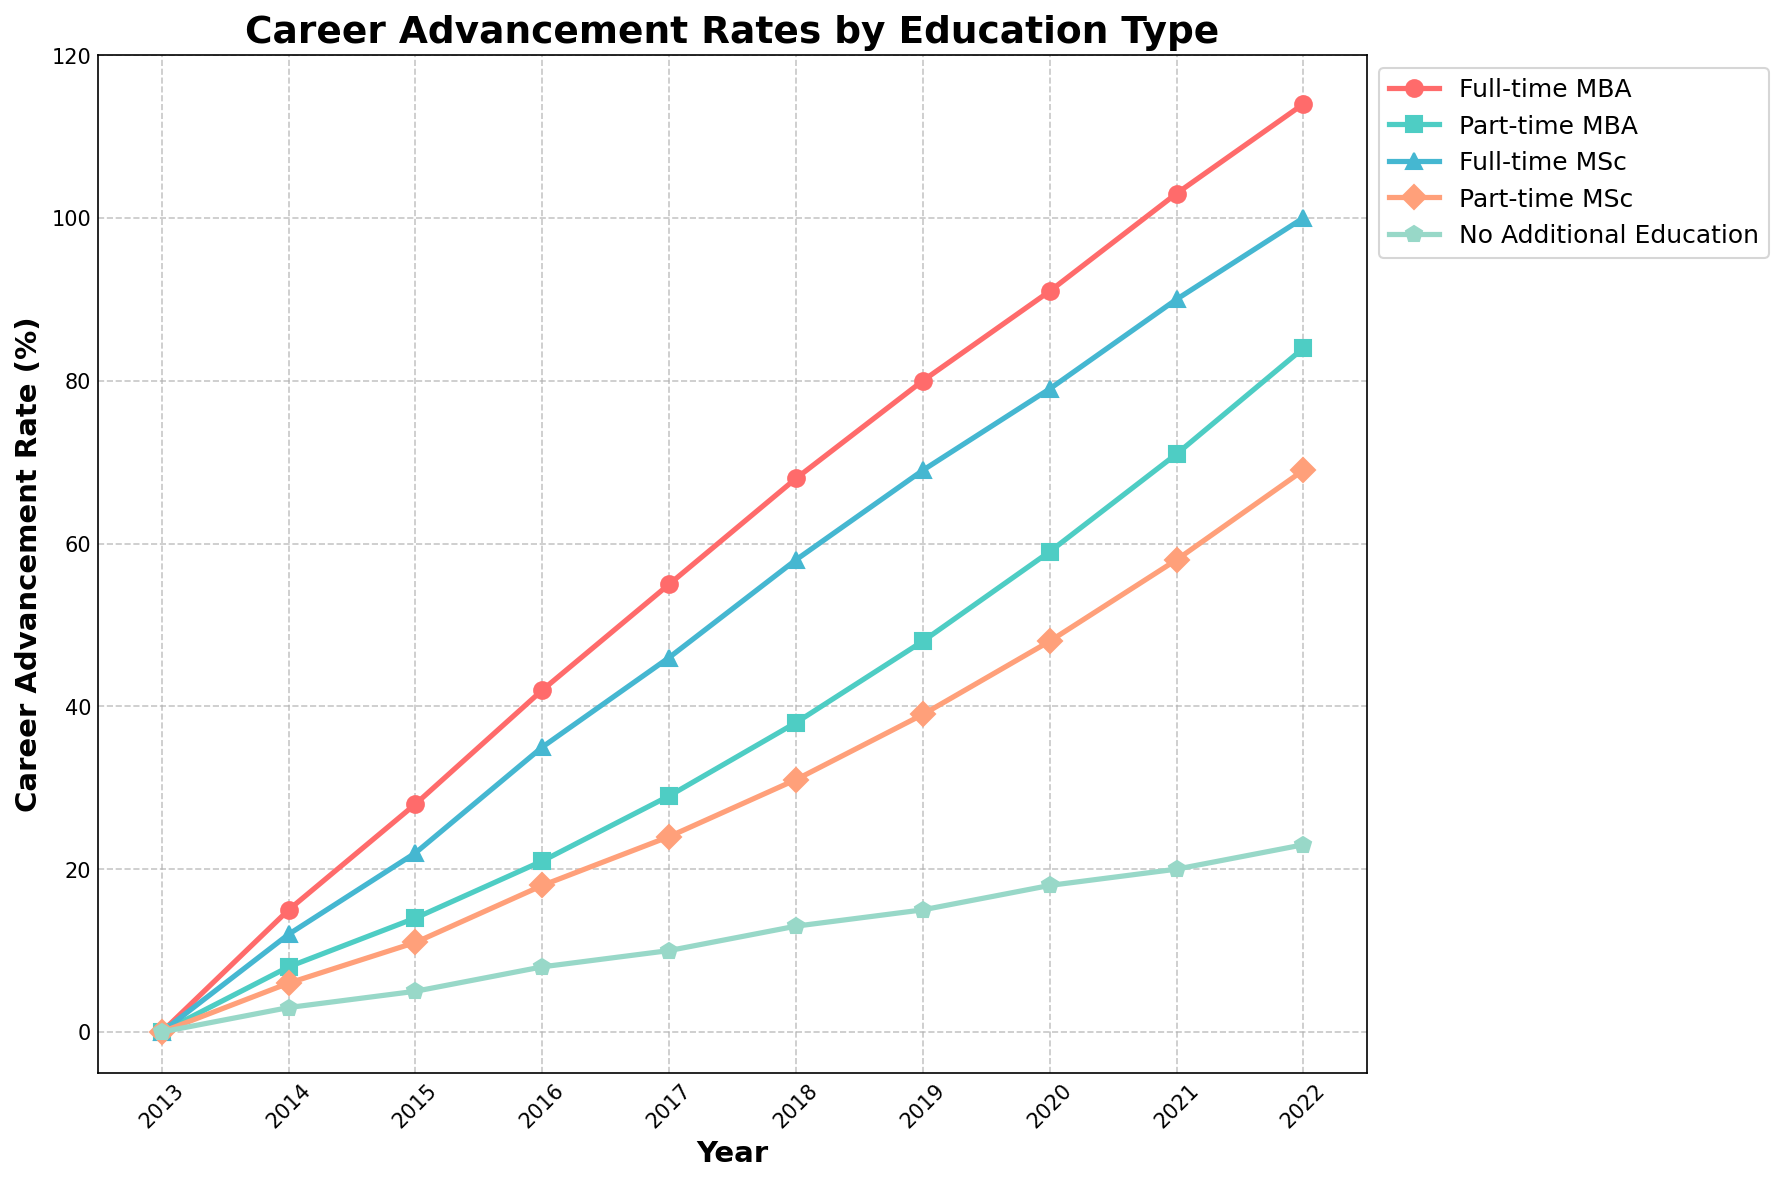When did the career advancement rates for full-time education types (MBA + MSc) first exceed 100% combined? To find the year when the combined career advancement rates for full-time MBA and full-time MSc exceeded 100%, add the values from both columns for each year. The first occurrence is in 2018 when Full-time MBA (68%) + Full-time MSc (58%) = 126%.
Answer: 2018 In which year did the part-time MSc rate surpass the part-time MBA rate? Compare the values of Part-time MSc and Part-time MBA for each year until Part-time MSc is greater than Part-time MBA. This first occurs in 2017 with Part-time MSc (24%) vs. Part-time MBA (21%).
Answer: 2017 What is the difference in career advancement rate between full-time MBA and no additional education in 2021? Subtract the career advancement rate of No Additional Education from Full-time MBA for the year 2021. Full-time MBA is 103%, and No Additional Education is 20%, so 103 - 20 = 83.
Answer: 83% On average, how much did the career advancement rate increase per year for employees pursuing a part-time MBA from 2014 to 2022? To calculate the average yearly increase, find the difference in advancement rates from 2022 (84%) and 2014 (8%), then divide by the number of years: (84 - 8) / (2022 - 2014) = 76 / 8 = 9.5% per year on average.
Answer: 9.5% What is the combined career advancement rate of part-time education types (MBA + MSc) in 2020? Add the rates for Part-time MBA and Part-time MSc for the year 2020: Part-time MBA (59%) + Part-time MSc (48%) = 107%.
Answer: 107% Which education type had the closest advancement rate to 50% in 2017? Check the values for each education type for the year 2017 and find the one closest to 50%. Part-time MSc is 24%, Part-time MBA is 21%. Among full-time, Full-time MSc is 46%, and Full-time MBA is 55%. The closest is Full-time MSc with 46%.
Answer: Full-time MSc When did the career advancement rate for full-time MSc first exceed the rate for part-time MBA? Compare Full-time MSc with Part-time MBA rates year by year until Full-time MSc is greater. First occurrence is 2015: Full-time MSc (22%) vs. Part-time MBA (14%).
Answer: 2015 What is the median career advancement rate for No Additional Education from 2014 to 2022? List the rates of No Additional Education from 2014 to 2022 (3, 5, 8, 10, 13, 15, 18, 20, 23). The median is the middle value in this ordered list, so (13 is the 5th value).
Answer: 13% 